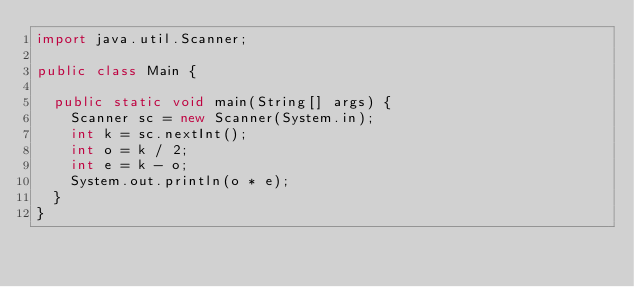Convert code to text. <code><loc_0><loc_0><loc_500><loc_500><_Java_>import java.util.Scanner;

public class Main {

	public static void main(String[] args) {
		Scanner sc = new Scanner(System.in);
		int k = sc.nextInt();
		int o = k / 2;
		int e = k - o;
		System.out.println(o * e);
	}
}</code> 